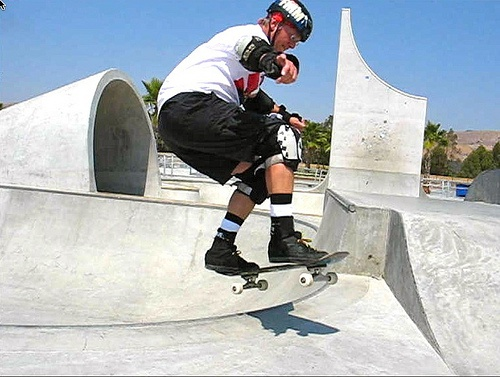Describe the objects in this image and their specific colors. I can see people in lightgray, black, white, gray, and darkgray tones and skateboard in lightgray, gray, black, darkgray, and ivory tones in this image. 